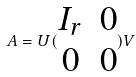<formula> <loc_0><loc_0><loc_500><loc_500>A = U ( \begin{matrix} I _ { r } & 0 \\ 0 & 0 \end{matrix} ) V</formula> 